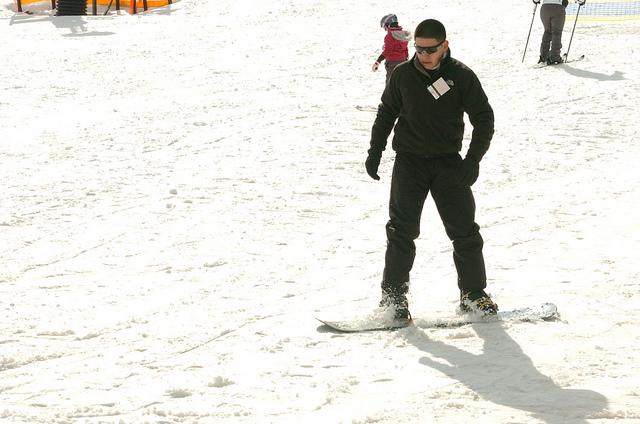Is this man skiing or snowboarding?
Short answer required. Snowboarding. Is it raining?
Short answer required. No. Does the man have a shadow?
Keep it brief. Yes. 